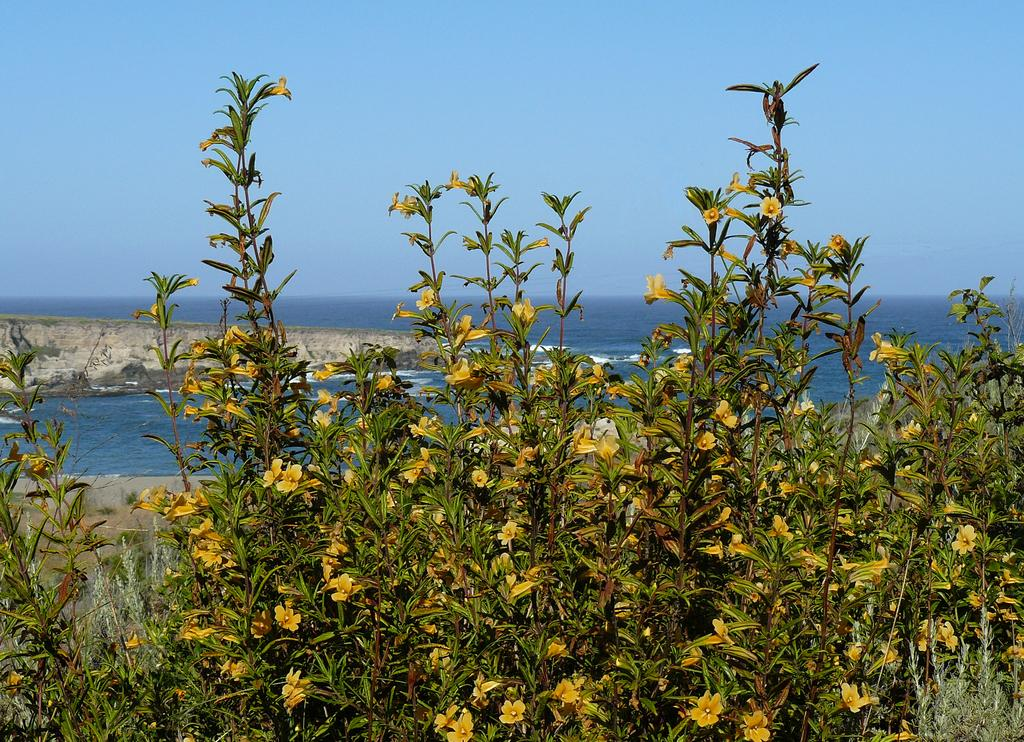What type of plants can be seen in the image? There are plants with yellow flowers in the image. What can be seen in the distance behind the plants? There is an ocean in the background of the image. How would you describe the sky in the image? The sky is clear in the image. What type of agreement is being signed in the image? There is no indication of a signing or agreement in the image; it features plants with yellow flowers and an ocean in the background. 